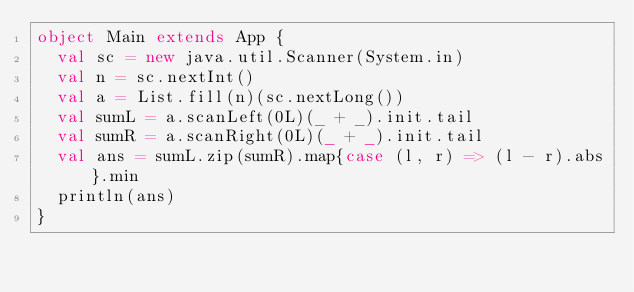<code> <loc_0><loc_0><loc_500><loc_500><_Scala_>object Main extends App {
  val sc = new java.util.Scanner(System.in)
  val n = sc.nextInt()
  val a = List.fill(n)(sc.nextLong())
  val sumL = a.scanLeft(0L)(_ + _).init.tail
  val sumR = a.scanRight(0L)(_ + _).init.tail
  val ans = sumL.zip(sumR).map{case (l, r) => (l - r).abs}.min
  println(ans)
}
</code> 